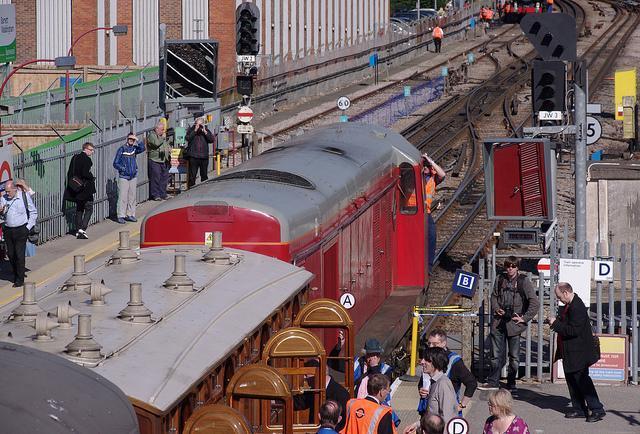How many people are in the photo?
Give a very brief answer. 8. 